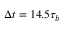Convert formula to latex. <formula><loc_0><loc_0><loc_500><loc_500>\Delta t = 1 4 . 5 \tau _ { b }</formula> 